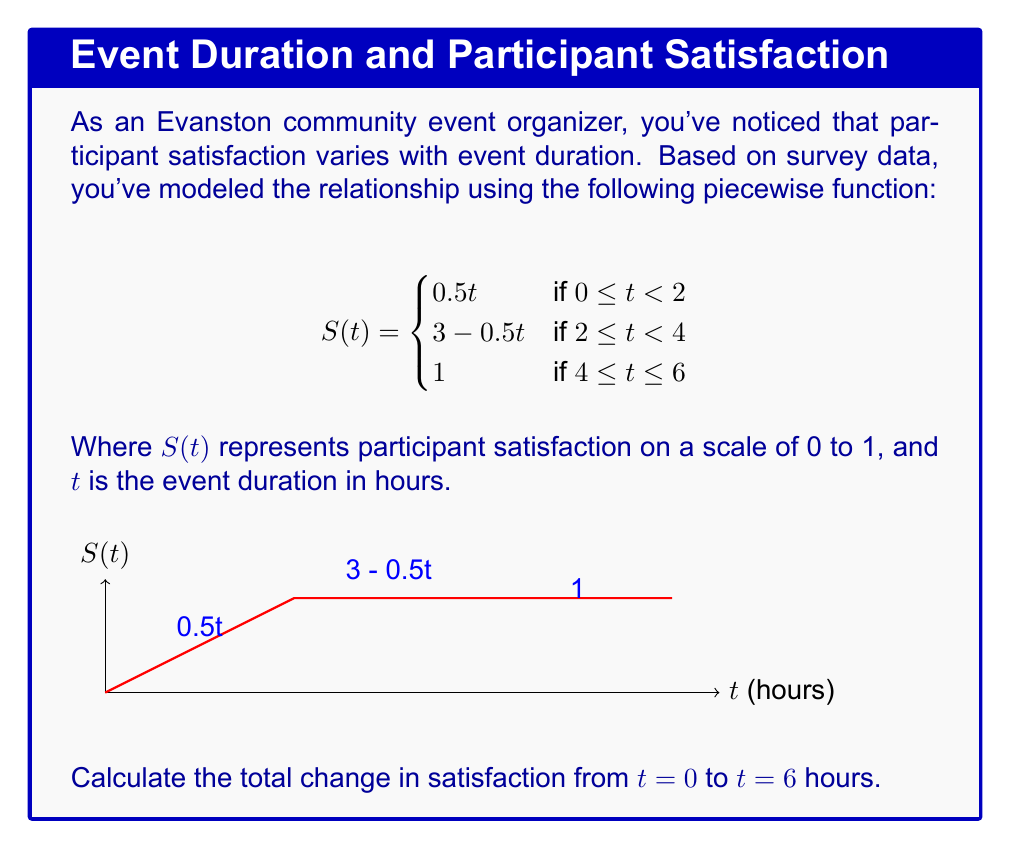Provide a solution to this math problem. To calculate the total change in satisfaction from t = 0 to t = 6 hours, we need to evaluate the function at the endpoints and find the difference.

Step 1: Evaluate S(0)
At t = 0, we use the first piece of the function:
$S(0) = 0.5(0) = 0$

Step 2: Evaluate S(6)
At t = 6, we use the third piece of the function:
$S(6) = 1$

Step 3: Calculate the change in satisfaction
Change in satisfaction = S(6) - S(0) = 1 - 0 = 1

Therefore, the total change in satisfaction from t = 0 to t = 6 hours is 1.

Note: This result makes sense intuitively as well. The satisfaction starts at 0 when the event hasn't begun (t = 0) and reaches its maximum value of 1 by the end of the 6-hour period.
Answer: 1 